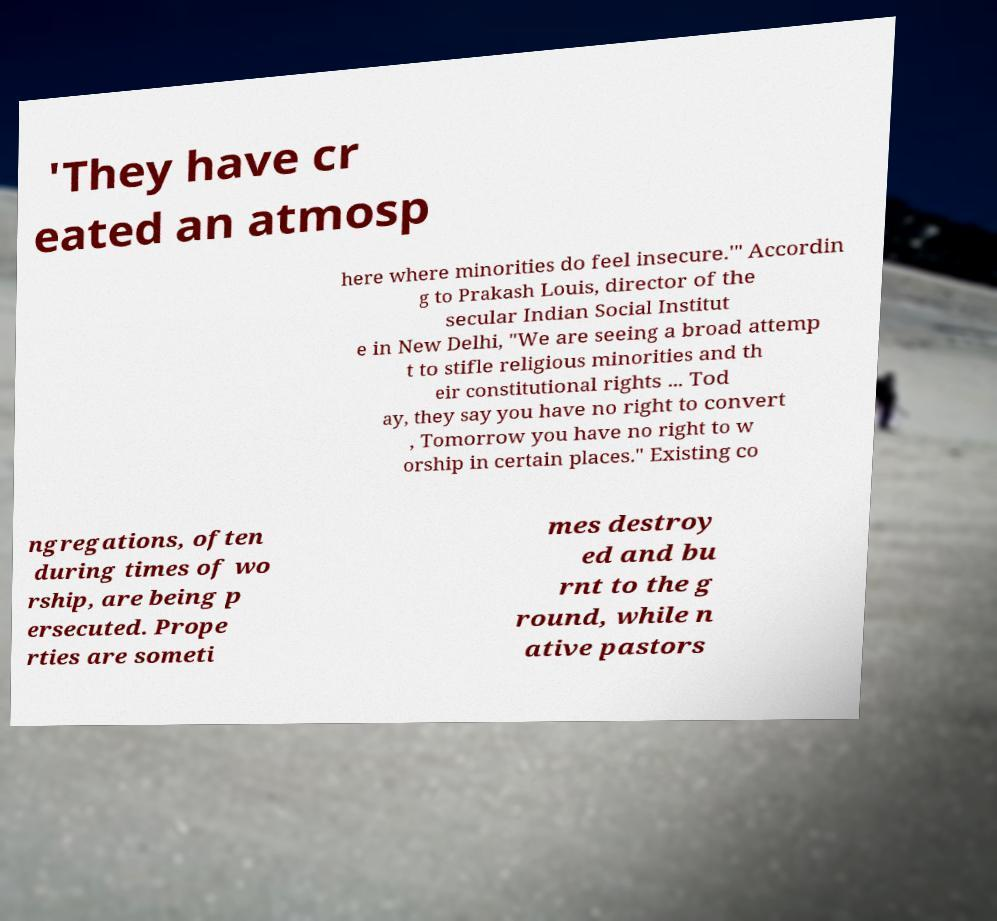Please identify and transcribe the text found in this image. 'They have cr eated an atmosp here where minorities do feel insecure.'" Accordin g to Prakash Louis, director of the secular Indian Social Institut e in New Delhi, "We are seeing a broad attemp t to stifle religious minorities and th eir constitutional rights ... Tod ay, they say you have no right to convert , Tomorrow you have no right to w orship in certain places." Existing co ngregations, often during times of wo rship, are being p ersecuted. Prope rties are someti mes destroy ed and bu rnt to the g round, while n ative pastors 